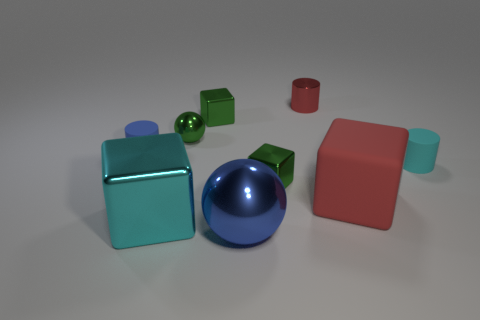Are there any other things of the same color as the big sphere?
Your response must be concise. Yes. There is a tiny rubber cylinder that is to the left of the sphere that is behind the matte cylinder on the left side of the red matte thing; what color is it?
Your answer should be compact. Blue. Does the small green object in front of the small shiny sphere have the same shape as the tiny blue thing?
Give a very brief answer. No. What material is the tiny ball?
Your answer should be compact. Metal. What shape is the cyan thing to the right of the tiny cube in front of the blue object that is behind the big red object?
Provide a short and direct response. Cylinder. How many other objects are there of the same shape as the blue shiny object?
Keep it short and to the point. 1. There is a small sphere; does it have the same color as the rubber cylinder on the right side of the large blue metallic sphere?
Ensure brevity in your answer.  No. How many brown matte spheres are there?
Ensure brevity in your answer.  0. How many things are tiny metal things or red cylinders?
Provide a succinct answer. 4. There is a thing that is the same color as the big shiny block; what size is it?
Provide a short and direct response. Small. 